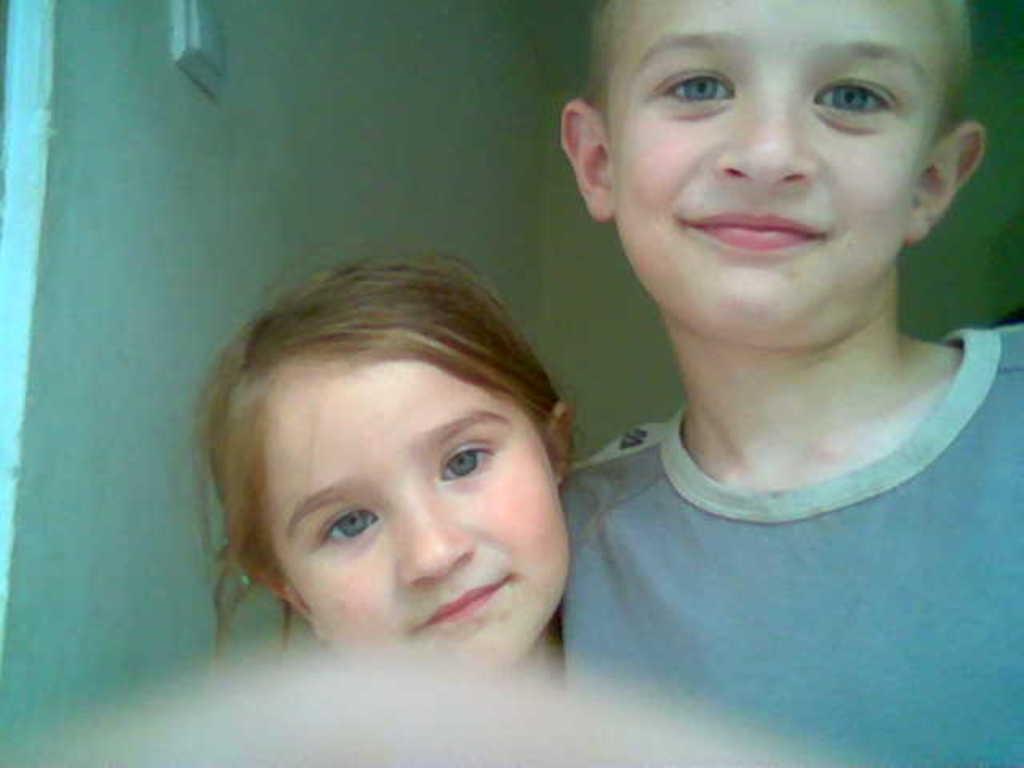Please provide a concise description of this image. In the picture there are two people, a boy and a girl and behind them there is a wall. 